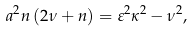Convert formula to latex. <formula><loc_0><loc_0><loc_500><loc_500>a ^ { 2 } n \left ( 2 \nu + n \right ) = \varepsilon ^ { 2 } \kappa ^ { 2 } - \nu ^ { 2 } ,</formula> 